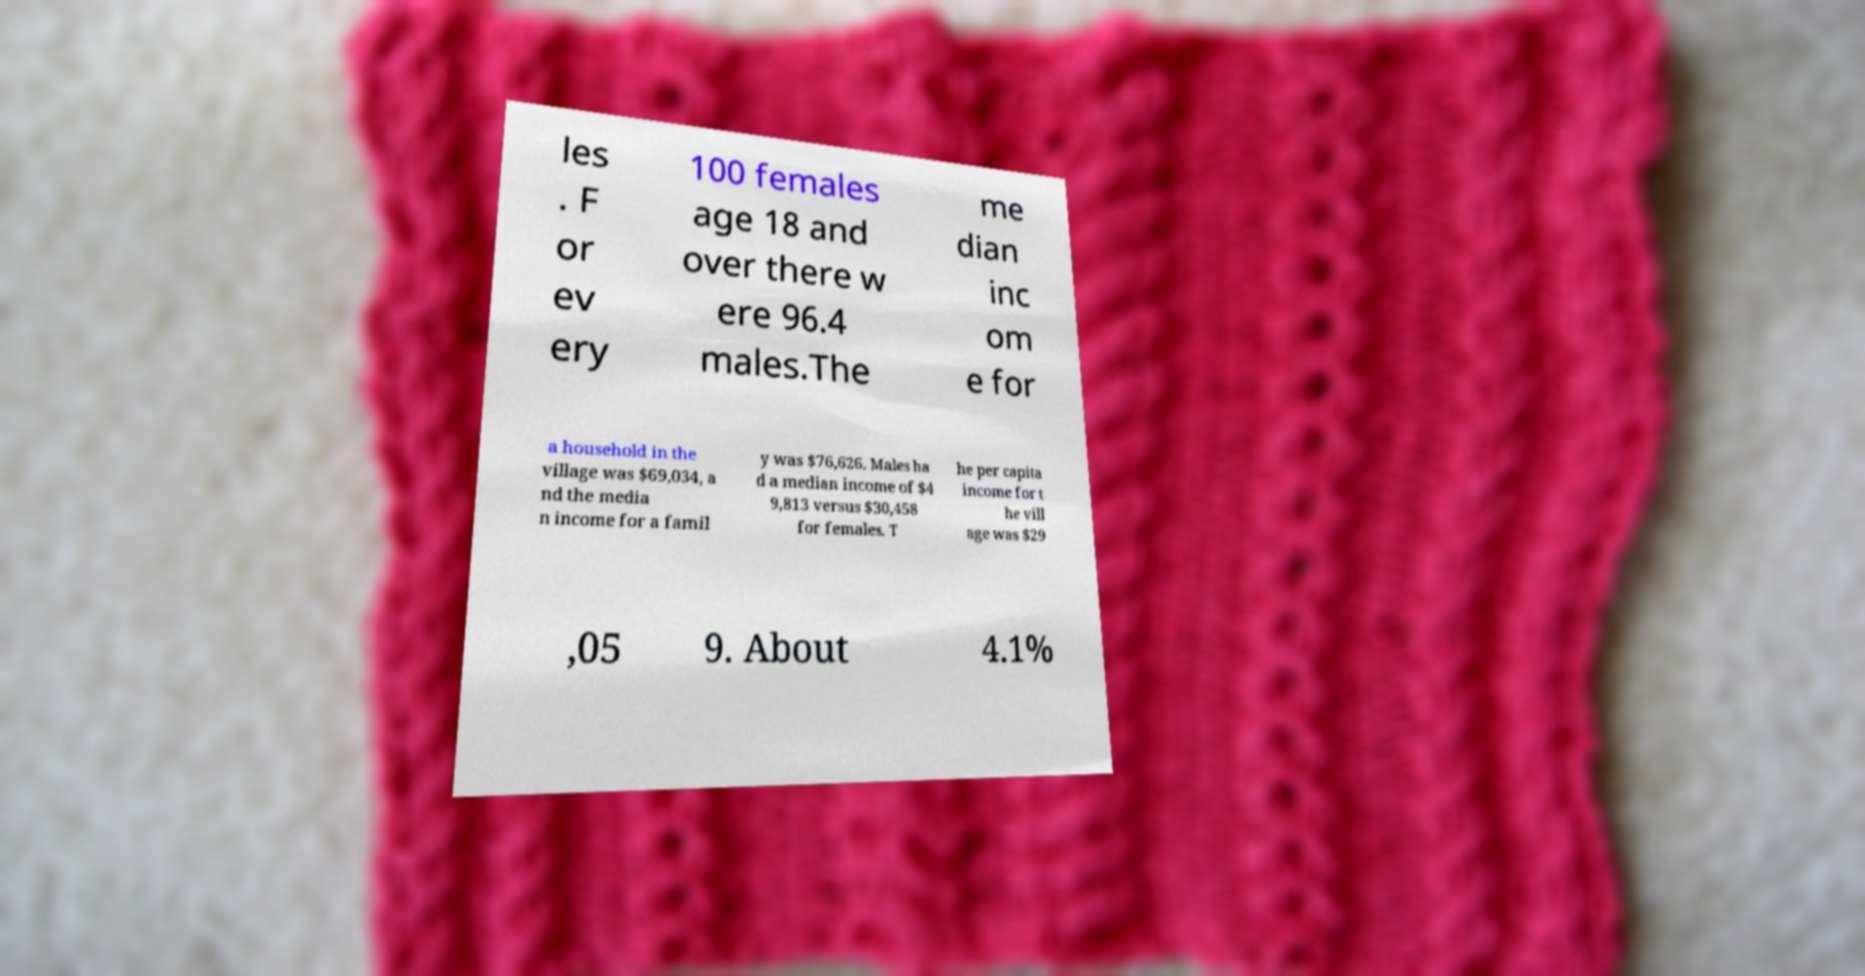Can you accurately transcribe the text from the provided image for me? les . F or ev ery 100 females age 18 and over there w ere 96.4 males.The me dian inc om e for a household in the village was $69,034, a nd the media n income for a famil y was $76,626. Males ha d a median income of $4 9,813 versus $30,458 for females. T he per capita income for t he vill age was $29 ,05 9. About 4.1% 